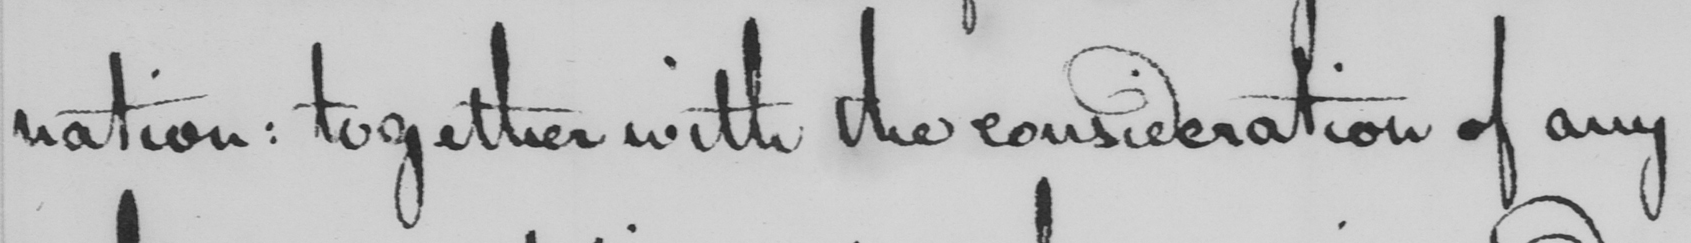Can you read and transcribe this handwriting? nation :  together with the consideration of any 